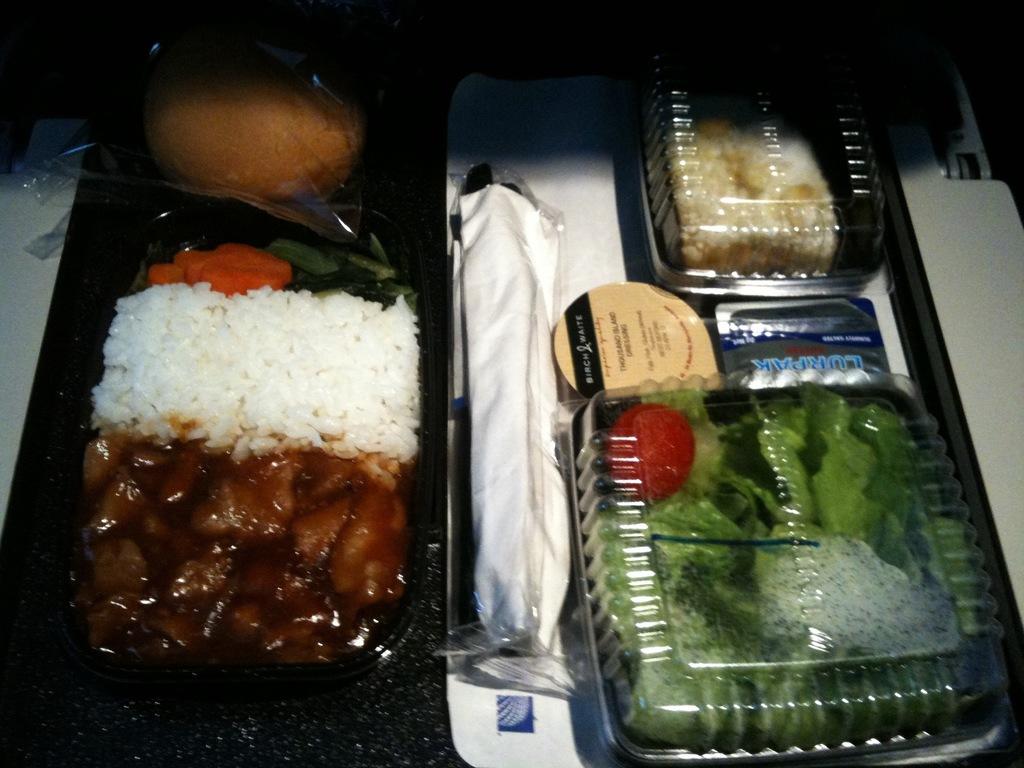What is behind the salad?
Keep it short and to the point. Thousand island dressing. 